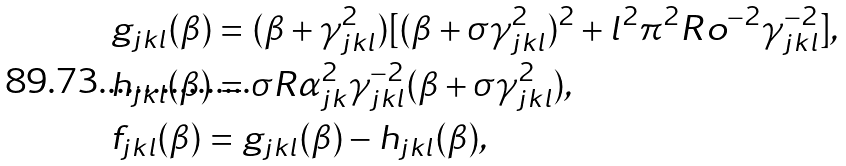<formula> <loc_0><loc_0><loc_500><loc_500>& g _ { j k l } ( \beta ) = ( \beta + \gamma _ { j k l } ^ { 2 } ) [ ( \beta + \sigma \gamma _ { j k l } ^ { 2 } ) ^ { 2 } + l ^ { 2 } \pi ^ { 2 } R o ^ { - 2 } \gamma _ { j k l } ^ { - 2 } ] , \\ & h _ { j k l } ( \beta ) = \sigma R \alpha _ { j k } ^ { 2 } \gamma _ { j k l } ^ { - 2 } ( \beta + \sigma \gamma _ { j k l } ^ { 2 } ) , \\ & f _ { j k l } ( \beta ) = g _ { j k l } ( \beta ) - h _ { j k l } ( \beta ) , \\</formula> 